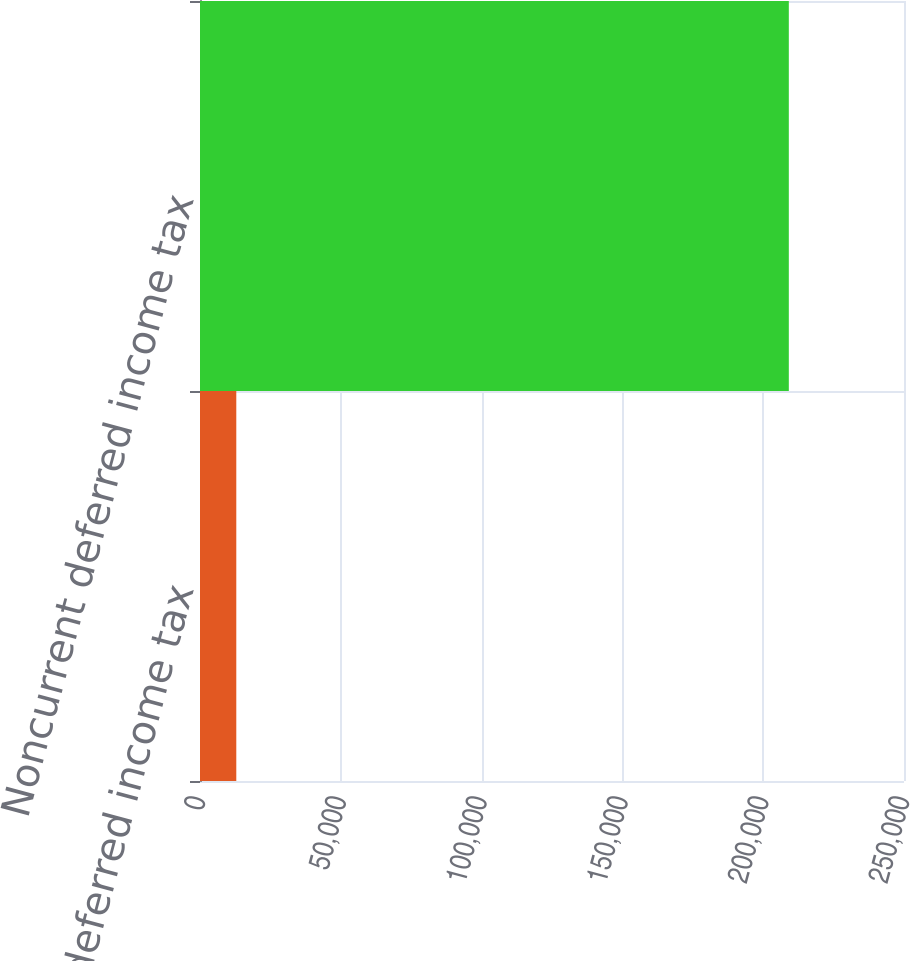Convert chart. <chart><loc_0><loc_0><loc_500><loc_500><bar_chart><fcel>Current deferred income tax<fcel>Noncurrent deferred income tax<nl><fcel>12887<fcel>209099<nl></chart> 